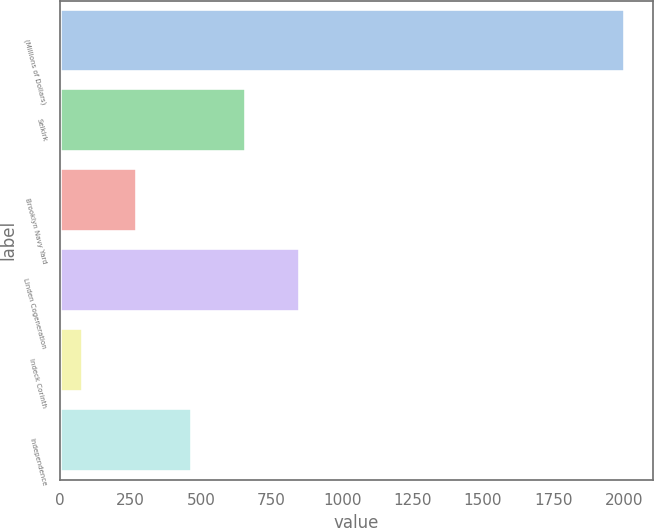<chart> <loc_0><loc_0><loc_500><loc_500><bar_chart><fcel>(Millions of Dollars)<fcel>Selkirk<fcel>Brooklyn Navy Yard<fcel>Linden Cogeneration<fcel>Indeck Corinth<fcel>Independence<nl><fcel>2002<fcel>658<fcel>274<fcel>850<fcel>82<fcel>466<nl></chart> 